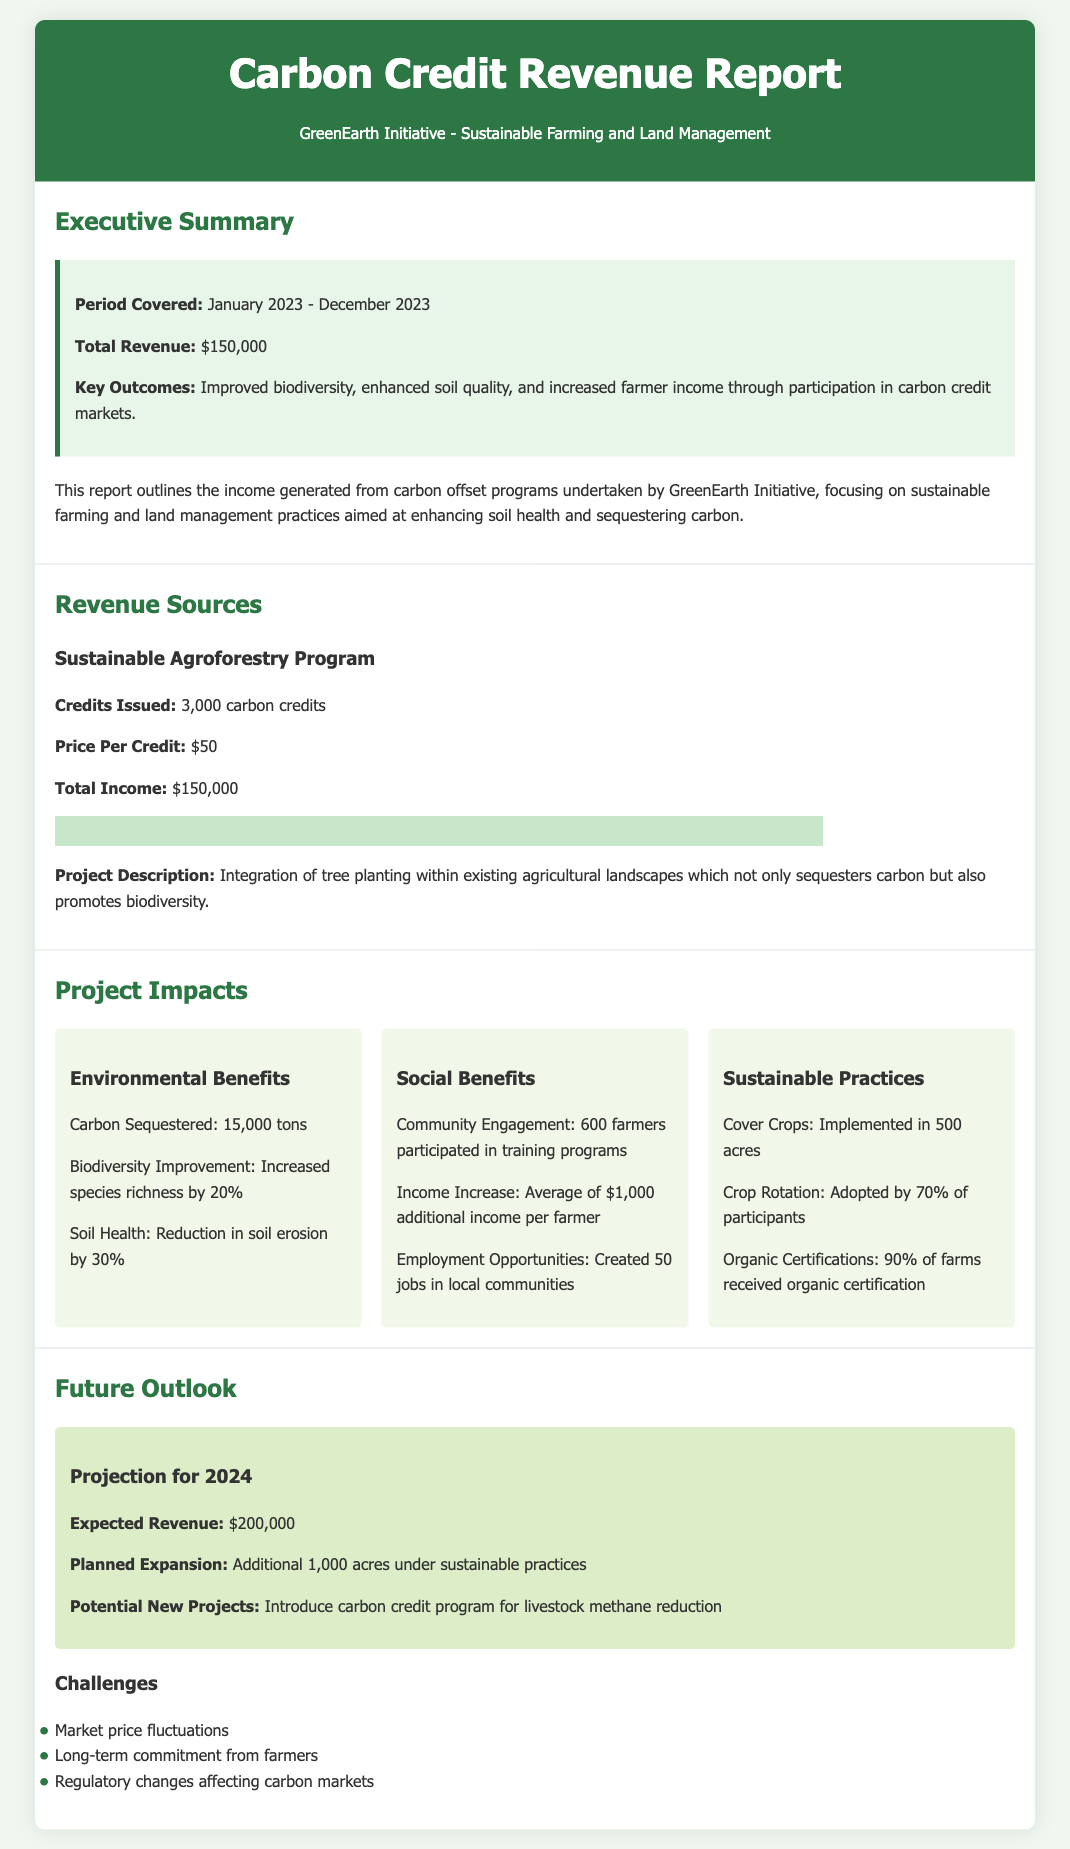what is the period covered in the report? The period covered is specified in the Executive Summary section of the document.
Answer: January 2023 - December 2023 what is the total revenue generated? The total revenue is summarized in the Executive Summary section of the document.
Answer: $150,000 how many carbon credits were issued in the Sustainable Agroforestry Program? The number of carbon credits issued is detailed under the Revenue Sources section for the Sustainable Agroforestry Program.
Answer: 3,000 carbon credits what is the carbon sequestered in tons as mentioned in the Project Impacts? The total carbon sequestered is provided in the Environmental Benefits subsection of the Project Impacts section.
Answer: 15,000 tons how many farmers participated in the training programs? The number of farmers who engaged in the training programs is provided under the Social Benefits subsection of Project Impacts.
Answer: 600 farmers what is the expected revenue for 2024? The expected revenue for 2024 is outlined in the Future Outlook section of the document.
Answer: $200,000 which sustainable practice was implemented in 500 acres? The specific sustainable practice is listed in the Sustainable Practices subsection of the Project Impacts.
Answer: Cover Crops what percentage of farms received organic certification? The percentage of farms achieving organic certification is mentioned in the Sustainable Practices subsection under Project Impacts.
Answer: 90% of farms what is a potential new project mentioned for the future? The potential new project is described in the Future Outlook section of the document.
Answer: Introduce carbon credit program for livestock methane reduction 